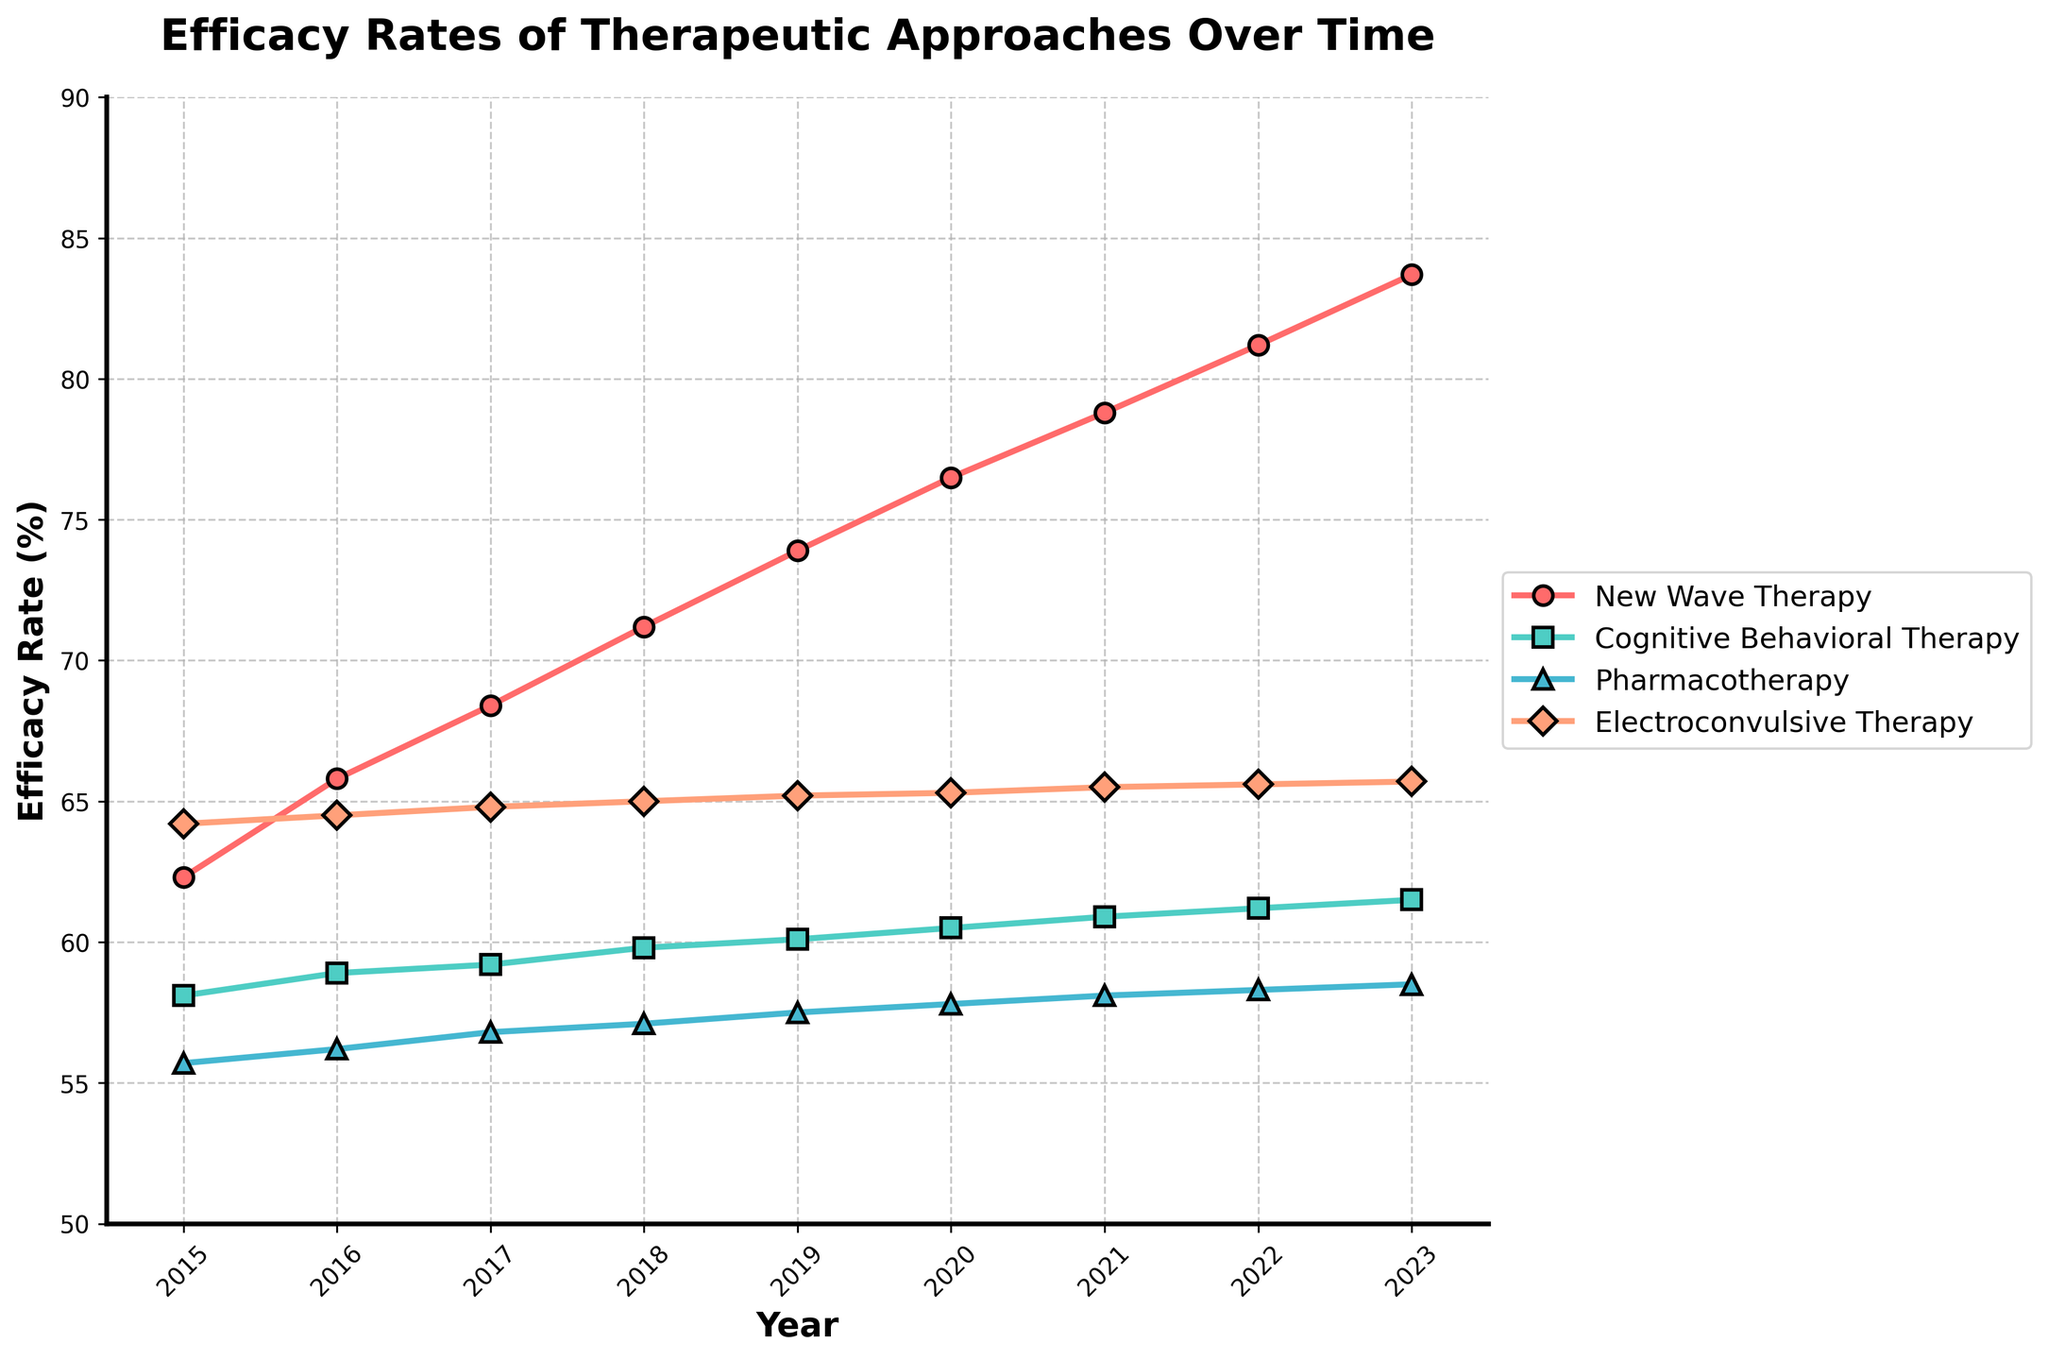What is the average efficacy rate of New Wave Therapy from 2015 to 2023? To find the average efficacy rate, sum the values for New Wave Therapy from 2015 to 2023 and divide by the number of years. Sum = 62.3 + 65.8 + 68.4 + 71.2 + 73.9 + 76.5 + 78.8 + 81.2 + 83.7 = 661.8. Number of years = 9. Average = 661.8 / 9 = 73.53
Answer: 73.53 Which therapy has the highest efficacy rate in 2023? In 2023, compare the efficacy rates of all the therapies. New Wave Therapy = 83.7, Cognitive Behavioral Therapy = 61.5, Pharmacotherapy = 58.5, Electroconvulsive Therapy = 65.7. New Wave Therapy has the highest value.
Answer: New Wave Therapy What is the difference in efficacy rates between New Wave Therapy and Electroconvulsive Therapy in 2021? Subtract the efficacy rate of Electroconvulsive Therapy from that of New Wave Therapy in 2021. New Wave Therapy (2021) = 78.8, Electroconvulsive Therapy (2021) = 65.5. Difference = 78.8 - 65.5 = 13.3
Answer: 13.3 In which year did New Wave Therapy surpass 70% efficacy for the first time? Look for the first year where New Wave Therapy's efficacy is above 70%. In 2018, New Wave Therapy's efficacy is 71.2%, which is the first instance it surpasses 70%.
Answer: 2018 What's the trend of Cognitive Behavioral Therapy's efficacy rate from 2015 to 2023? Observe the changes in the efficacy rate of Cognitive Behavioral Therapy over the years. It gradually increases from 58.1 in 2015 to 61.5 in 2023. The trend is steadily upward.
Answer: Upward trend In which year is the efficacy rate of Pharmacotherapy closest to 58%? Check which year has the efficacy rate of Pharmacotherapy closest to 58%. Pharmacotherapy has an efficacy of 58.1 in 2021. The closest value to 58%.
Answer: 2021 Which therapy had a relatively constant efficacy rate from 2015 to 2023? Examine each therapy's trend over the years. Electroconvulsive Therapy has minimally fluctuated from 64.2 in 2015 to 65.7 in 2023, remaining relatively constant.
Answer: Electroconvulsive Therapy How many therapies had an efficacy rate above 60% in 2020? Compare the efficacy rates of all therapies in 2020. New Wave Therapy = 76.5, Cognitive Behavioral Therapy = 60.5, Pharmacotherapy = 57.8, Electroconvulsive Therapy = 65.3. Count how many are above 60%. Three therapies (New Wave Therapy, Cognitive Behavioral Therapy, Electroconvulsive Therapy) had rates above 60%.
Answer: 3 Is there any year where the efficacy rate of Cognitive Behavioral Therapy increased by exactly 1% compared to the previous year? Compare each year's efficacy rate of Cognitive Behavioral Therapy to its previous year to find a 1% increase. 2015 = 58.1, 2016 = 58.9 (+0.8%), 2017 = 59.2 (+0.3%), 2018 = 59.8 (+0.6%), 2019 = 60.1 (+0.3), 2020 = 60.5 (+0.4%), 2021 = 60.9 (+0.4), 2022 = 61.2 (+0.3%), 2023 = 61.5 (+0.3%). No such year was found.
Answer: No What is the combined increase in efficacy rate of New Wave Therapy from 2015 to 2023? Find the difference between 2023 and 2015 efficacy rates for New Wave Therapy. 2023 = 83.7, 2015 = 62.3. Increase = 83.7 - 62.3 = 21.4
Answer: 21.4 